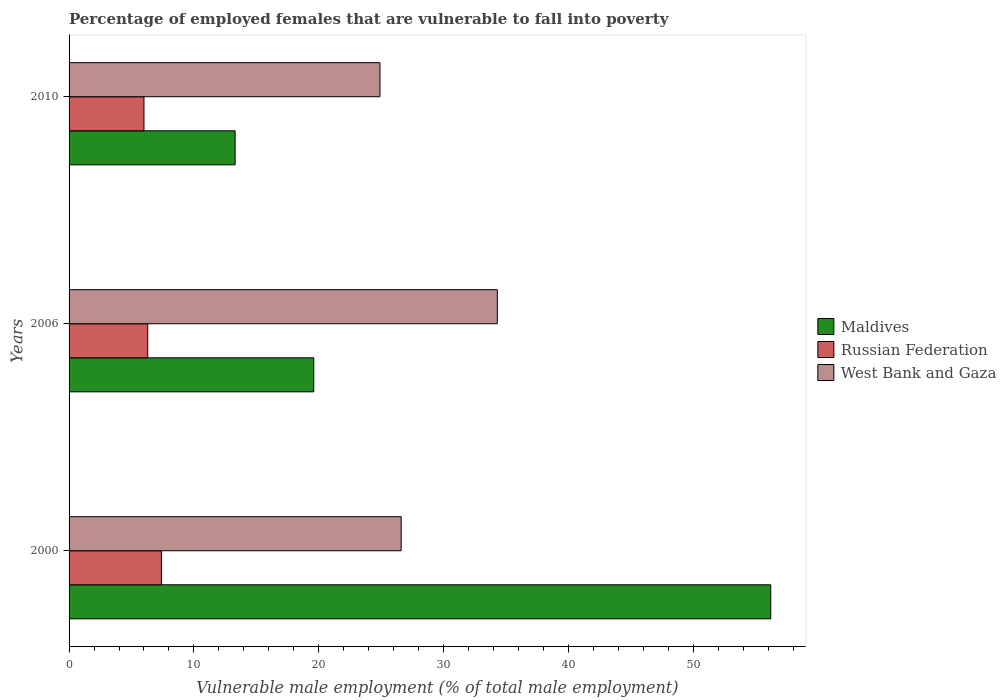How many different coloured bars are there?
Make the answer very short. 3. Are the number of bars on each tick of the Y-axis equal?
Give a very brief answer. Yes. How many bars are there on the 2nd tick from the bottom?
Offer a terse response. 3. What is the label of the 2nd group of bars from the top?
Provide a succinct answer. 2006. What is the percentage of employed females who are vulnerable to fall into poverty in Maldives in 2010?
Your answer should be very brief. 13.3. Across all years, what is the maximum percentage of employed females who are vulnerable to fall into poverty in Russian Federation?
Keep it short and to the point. 7.4. Across all years, what is the minimum percentage of employed females who are vulnerable to fall into poverty in West Bank and Gaza?
Your answer should be very brief. 24.9. In which year was the percentage of employed females who are vulnerable to fall into poverty in Russian Federation maximum?
Give a very brief answer. 2000. In which year was the percentage of employed females who are vulnerable to fall into poverty in Russian Federation minimum?
Your response must be concise. 2010. What is the total percentage of employed females who are vulnerable to fall into poverty in Russian Federation in the graph?
Your response must be concise. 19.7. What is the difference between the percentage of employed females who are vulnerable to fall into poverty in Russian Federation in 2006 and that in 2010?
Ensure brevity in your answer.  0.3. What is the difference between the percentage of employed females who are vulnerable to fall into poverty in Russian Federation in 2010 and the percentage of employed females who are vulnerable to fall into poverty in West Bank and Gaza in 2006?
Your response must be concise. -28.3. What is the average percentage of employed females who are vulnerable to fall into poverty in West Bank and Gaza per year?
Your answer should be very brief. 28.6. In the year 2000, what is the difference between the percentage of employed females who are vulnerable to fall into poverty in Russian Federation and percentage of employed females who are vulnerable to fall into poverty in Maldives?
Offer a very short reply. -48.8. In how many years, is the percentage of employed females who are vulnerable to fall into poverty in Russian Federation greater than 6 %?
Provide a short and direct response. 2. What is the ratio of the percentage of employed females who are vulnerable to fall into poverty in West Bank and Gaza in 2000 to that in 2010?
Ensure brevity in your answer.  1.07. Is the percentage of employed females who are vulnerable to fall into poverty in Maldives in 2000 less than that in 2006?
Offer a terse response. No. Is the difference between the percentage of employed females who are vulnerable to fall into poverty in Russian Federation in 2006 and 2010 greater than the difference between the percentage of employed females who are vulnerable to fall into poverty in Maldives in 2006 and 2010?
Offer a terse response. No. What is the difference between the highest and the second highest percentage of employed females who are vulnerable to fall into poverty in Maldives?
Offer a terse response. 36.6. What is the difference between the highest and the lowest percentage of employed females who are vulnerable to fall into poverty in Russian Federation?
Make the answer very short. 1.4. In how many years, is the percentage of employed females who are vulnerable to fall into poverty in Maldives greater than the average percentage of employed females who are vulnerable to fall into poverty in Maldives taken over all years?
Ensure brevity in your answer.  1. What does the 3rd bar from the top in 2000 represents?
Your response must be concise. Maldives. What does the 1st bar from the bottom in 2000 represents?
Provide a succinct answer. Maldives. Is it the case that in every year, the sum of the percentage of employed females who are vulnerable to fall into poverty in West Bank and Gaza and percentage of employed females who are vulnerable to fall into poverty in Maldives is greater than the percentage of employed females who are vulnerable to fall into poverty in Russian Federation?
Ensure brevity in your answer.  Yes. What is the difference between two consecutive major ticks on the X-axis?
Make the answer very short. 10. Are the values on the major ticks of X-axis written in scientific E-notation?
Make the answer very short. No. Does the graph contain any zero values?
Give a very brief answer. No. Does the graph contain grids?
Offer a very short reply. No. Where does the legend appear in the graph?
Offer a terse response. Center right. How are the legend labels stacked?
Make the answer very short. Vertical. What is the title of the graph?
Provide a short and direct response. Percentage of employed females that are vulnerable to fall into poverty. What is the label or title of the X-axis?
Make the answer very short. Vulnerable male employment (% of total male employment). What is the Vulnerable male employment (% of total male employment) of Maldives in 2000?
Your response must be concise. 56.2. What is the Vulnerable male employment (% of total male employment) in Russian Federation in 2000?
Give a very brief answer. 7.4. What is the Vulnerable male employment (% of total male employment) in West Bank and Gaza in 2000?
Your response must be concise. 26.6. What is the Vulnerable male employment (% of total male employment) in Maldives in 2006?
Give a very brief answer. 19.6. What is the Vulnerable male employment (% of total male employment) in Russian Federation in 2006?
Your answer should be very brief. 6.3. What is the Vulnerable male employment (% of total male employment) of West Bank and Gaza in 2006?
Your response must be concise. 34.3. What is the Vulnerable male employment (% of total male employment) in Maldives in 2010?
Make the answer very short. 13.3. What is the Vulnerable male employment (% of total male employment) in Russian Federation in 2010?
Your answer should be very brief. 6. What is the Vulnerable male employment (% of total male employment) of West Bank and Gaza in 2010?
Provide a short and direct response. 24.9. Across all years, what is the maximum Vulnerable male employment (% of total male employment) of Maldives?
Keep it short and to the point. 56.2. Across all years, what is the maximum Vulnerable male employment (% of total male employment) in Russian Federation?
Your answer should be compact. 7.4. Across all years, what is the maximum Vulnerable male employment (% of total male employment) in West Bank and Gaza?
Ensure brevity in your answer.  34.3. Across all years, what is the minimum Vulnerable male employment (% of total male employment) of Maldives?
Your answer should be very brief. 13.3. Across all years, what is the minimum Vulnerable male employment (% of total male employment) of Russian Federation?
Keep it short and to the point. 6. Across all years, what is the minimum Vulnerable male employment (% of total male employment) in West Bank and Gaza?
Provide a succinct answer. 24.9. What is the total Vulnerable male employment (% of total male employment) of Maldives in the graph?
Your answer should be compact. 89.1. What is the total Vulnerable male employment (% of total male employment) in West Bank and Gaza in the graph?
Give a very brief answer. 85.8. What is the difference between the Vulnerable male employment (% of total male employment) in Maldives in 2000 and that in 2006?
Offer a very short reply. 36.6. What is the difference between the Vulnerable male employment (% of total male employment) of Maldives in 2000 and that in 2010?
Make the answer very short. 42.9. What is the difference between the Vulnerable male employment (% of total male employment) in Maldives in 2006 and that in 2010?
Give a very brief answer. 6.3. What is the difference between the Vulnerable male employment (% of total male employment) of Russian Federation in 2006 and that in 2010?
Ensure brevity in your answer.  0.3. What is the difference between the Vulnerable male employment (% of total male employment) of Maldives in 2000 and the Vulnerable male employment (% of total male employment) of Russian Federation in 2006?
Ensure brevity in your answer.  49.9. What is the difference between the Vulnerable male employment (% of total male employment) in Maldives in 2000 and the Vulnerable male employment (% of total male employment) in West Bank and Gaza in 2006?
Make the answer very short. 21.9. What is the difference between the Vulnerable male employment (% of total male employment) in Russian Federation in 2000 and the Vulnerable male employment (% of total male employment) in West Bank and Gaza in 2006?
Make the answer very short. -26.9. What is the difference between the Vulnerable male employment (% of total male employment) in Maldives in 2000 and the Vulnerable male employment (% of total male employment) in Russian Federation in 2010?
Offer a terse response. 50.2. What is the difference between the Vulnerable male employment (% of total male employment) of Maldives in 2000 and the Vulnerable male employment (% of total male employment) of West Bank and Gaza in 2010?
Give a very brief answer. 31.3. What is the difference between the Vulnerable male employment (% of total male employment) of Russian Federation in 2000 and the Vulnerable male employment (% of total male employment) of West Bank and Gaza in 2010?
Give a very brief answer. -17.5. What is the difference between the Vulnerable male employment (% of total male employment) of Maldives in 2006 and the Vulnerable male employment (% of total male employment) of Russian Federation in 2010?
Make the answer very short. 13.6. What is the difference between the Vulnerable male employment (% of total male employment) of Maldives in 2006 and the Vulnerable male employment (% of total male employment) of West Bank and Gaza in 2010?
Offer a very short reply. -5.3. What is the difference between the Vulnerable male employment (% of total male employment) of Russian Federation in 2006 and the Vulnerable male employment (% of total male employment) of West Bank and Gaza in 2010?
Keep it short and to the point. -18.6. What is the average Vulnerable male employment (% of total male employment) of Maldives per year?
Your answer should be very brief. 29.7. What is the average Vulnerable male employment (% of total male employment) of Russian Federation per year?
Your answer should be very brief. 6.57. What is the average Vulnerable male employment (% of total male employment) of West Bank and Gaza per year?
Your answer should be very brief. 28.6. In the year 2000, what is the difference between the Vulnerable male employment (% of total male employment) in Maldives and Vulnerable male employment (% of total male employment) in Russian Federation?
Your answer should be very brief. 48.8. In the year 2000, what is the difference between the Vulnerable male employment (% of total male employment) in Maldives and Vulnerable male employment (% of total male employment) in West Bank and Gaza?
Provide a short and direct response. 29.6. In the year 2000, what is the difference between the Vulnerable male employment (% of total male employment) in Russian Federation and Vulnerable male employment (% of total male employment) in West Bank and Gaza?
Your answer should be very brief. -19.2. In the year 2006, what is the difference between the Vulnerable male employment (% of total male employment) in Maldives and Vulnerable male employment (% of total male employment) in West Bank and Gaza?
Offer a terse response. -14.7. In the year 2010, what is the difference between the Vulnerable male employment (% of total male employment) in Maldives and Vulnerable male employment (% of total male employment) in Russian Federation?
Ensure brevity in your answer.  7.3. In the year 2010, what is the difference between the Vulnerable male employment (% of total male employment) of Maldives and Vulnerable male employment (% of total male employment) of West Bank and Gaza?
Your answer should be very brief. -11.6. In the year 2010, what is the difference between the Vulnerable male employment (% of total male employment) in Russian Federation and Vulnerable male employment (% of total male employment) in West Bank and Gaza?
Keep it short and to the point. -18.9. What is the ratio of the Vulnerable male employment (% of total male employment) in Maldives in 2000 to that in 2006?
Offer a terse response. 2.87. What is the ratio of the Vulnerable male employment (% of total male employment) in Russian Federation in 2000 to that in 2006?
Your answer should be compact. 1.17. What is the ratio of the Vulnerable male employment (% of total male employment) in West Bank and Gaza in 2000 to that in 2006?
Offer a very short reply. 0.78. What is the ratio of the Vulnerable male employment (% of total male employment) in Maldives in 2000 to that in 2010?
Provide a succinct answer. 4.23. What is the ratio of the Vulnerable male employment (% of total male employment) in Russian Federation in 2000 to that in 2010?
Your response must be concise. 1.23. What is the ratio of the Vulnerable male employment (% of total male employment) in West Bank and Gaza in 2000 to that in 2010?
Offer a terse response. 1.07. What is the ratio of the Vulnerable male employment (% of total male employment) of Maldives in 2006 to that in 2010?
Your answer should be very brief. 1.47. What is the ratio of the Vulnerable male employment (% of total male employment) in West Bank and Gaza in 2006 to that in 2010?
Provide a succinct answer. 1.38. What is the difference between the highest and the second highest Vulnerable male employment (% of total male employment) of Maldives?
Give a very brief answer. 36.6. What is the difference between the highest and the second highest Vulnerable male employment (% of total male employment) of Russian Federation?
Make the answer very short. 1.1. What is the difference between the highest and the second highest Vulnerable male employment (% of total male employment) of West Bank and Gaza?
Provide a succinct answer. 7.7. What is the difference between the highest and the lowest Vulnerable male employment (% of total male employment) in Maldives?
Keep it short and to the point. 42.9. What is the difference between the highest and the lowest Vulnerable male employment (% of total male employment) in West Bank and Gaza?
Offer a terse response. 9.4. 